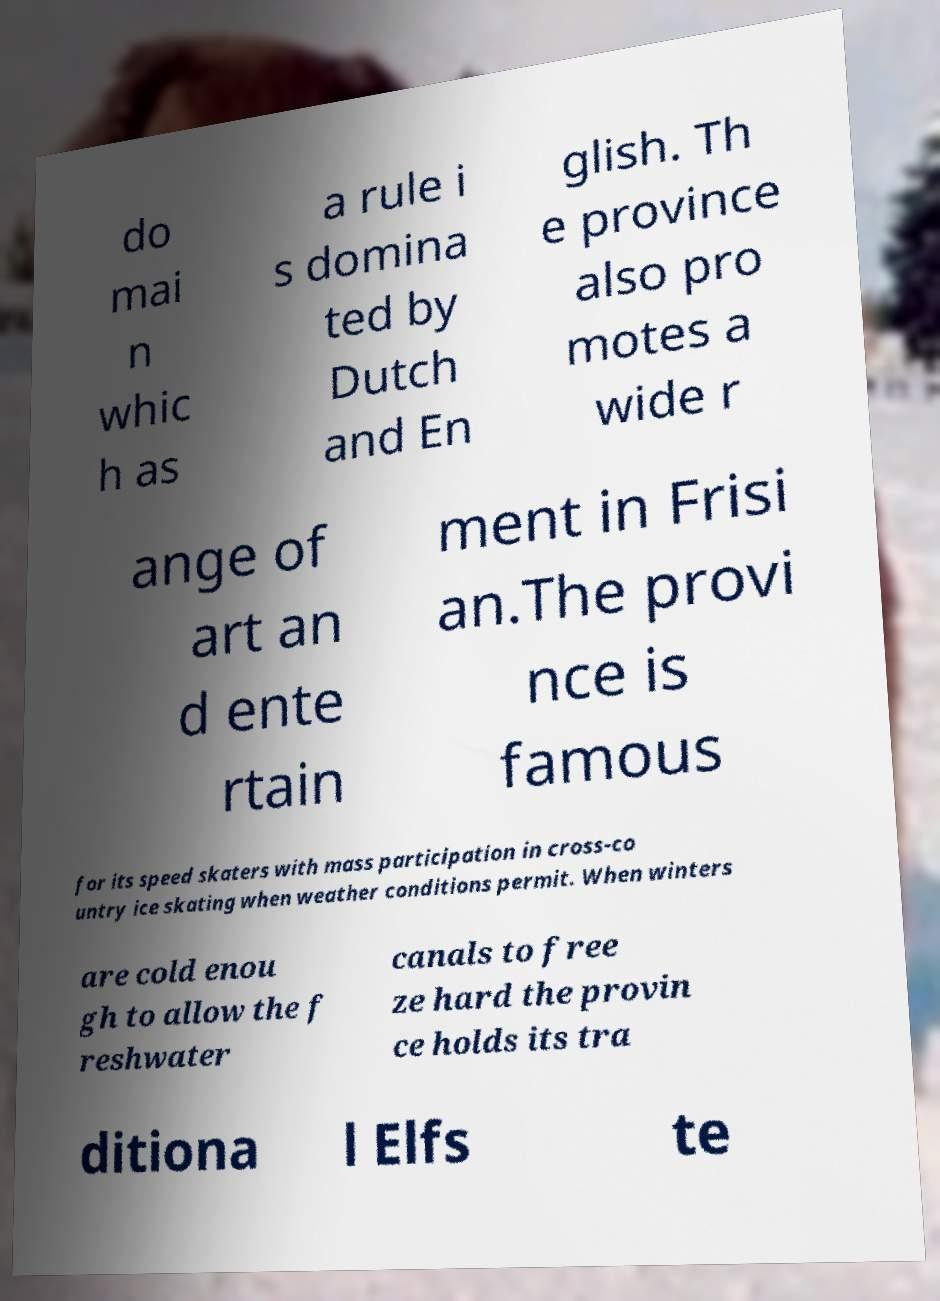I need the written content from this picture converted into text. Can you do that? do mai n whic h as a rule i s domina ted by Dutch and En glish. Th e province also pro motes a wide r ange of art an d ente rtain ment in Frisi an.The provi nce is famous for its speed skaters with mass participation in cross-co untry ice skating when weather conditions permit. When winters are cold enou gh to allow the f reshwater canals to free ze hard the provin ce holds its tra ditiona l Elfs te 